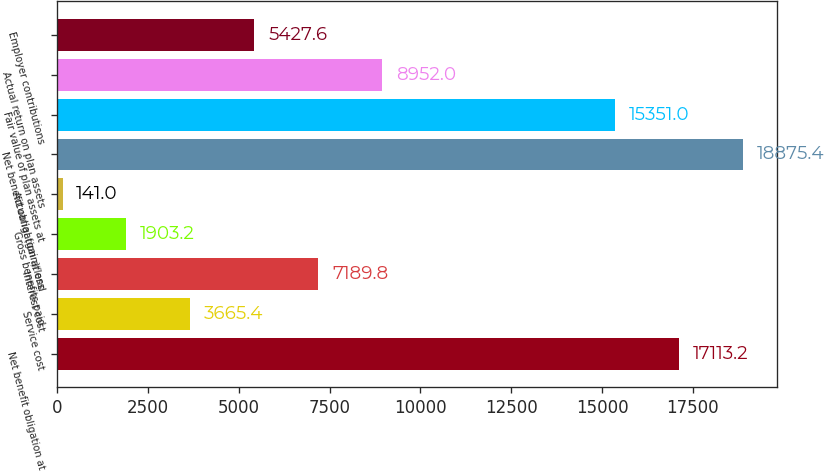Convert chart. <chart><loc_0><loc_0><loc_500><loc_500><bar_chart><fcel>Net benefit obligation at<fcel>Service cost<fcel>Interest cost<fcel>Gross benefits paid<fcel>Actuarial (gain)/loss<fcel>Net benefit obligation at end<fcel>Fair value of plan assets at<fcel>Actual return on plan assets<fcel>Employer contributions<nl><fcel>17113.2<fcel>3665.4<fcel>7189.8<fcel>1903.2<fcel>141<fcel>18875.4<fcel>15351<fcel>8952<fcel>5427.6<nl></chart> 